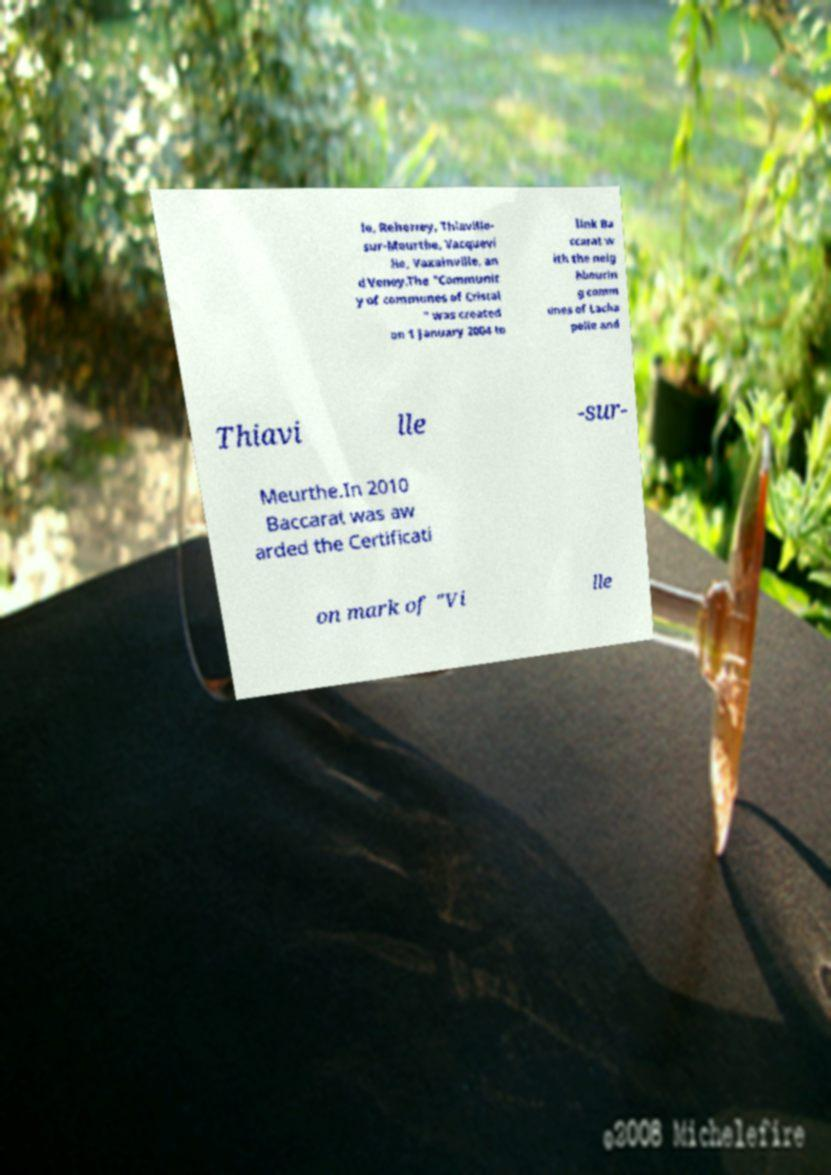What messages or text are displayed in this image? I need them in a readable, typed format. le, Reherrey, Thiaville- sur-Meurthe, Vacquevi lle, Vaxainville, an d Veney.The "Communit y of communes of Cristal " was created on 1 January 2004 to link Ba ccarat w ith the neig hbourin g comm unes of Lacha pelle and Thiavi lle -sur- Meurthe.In 2010 Baccarat was aw arded the Certificati on mark of "Vi lle 